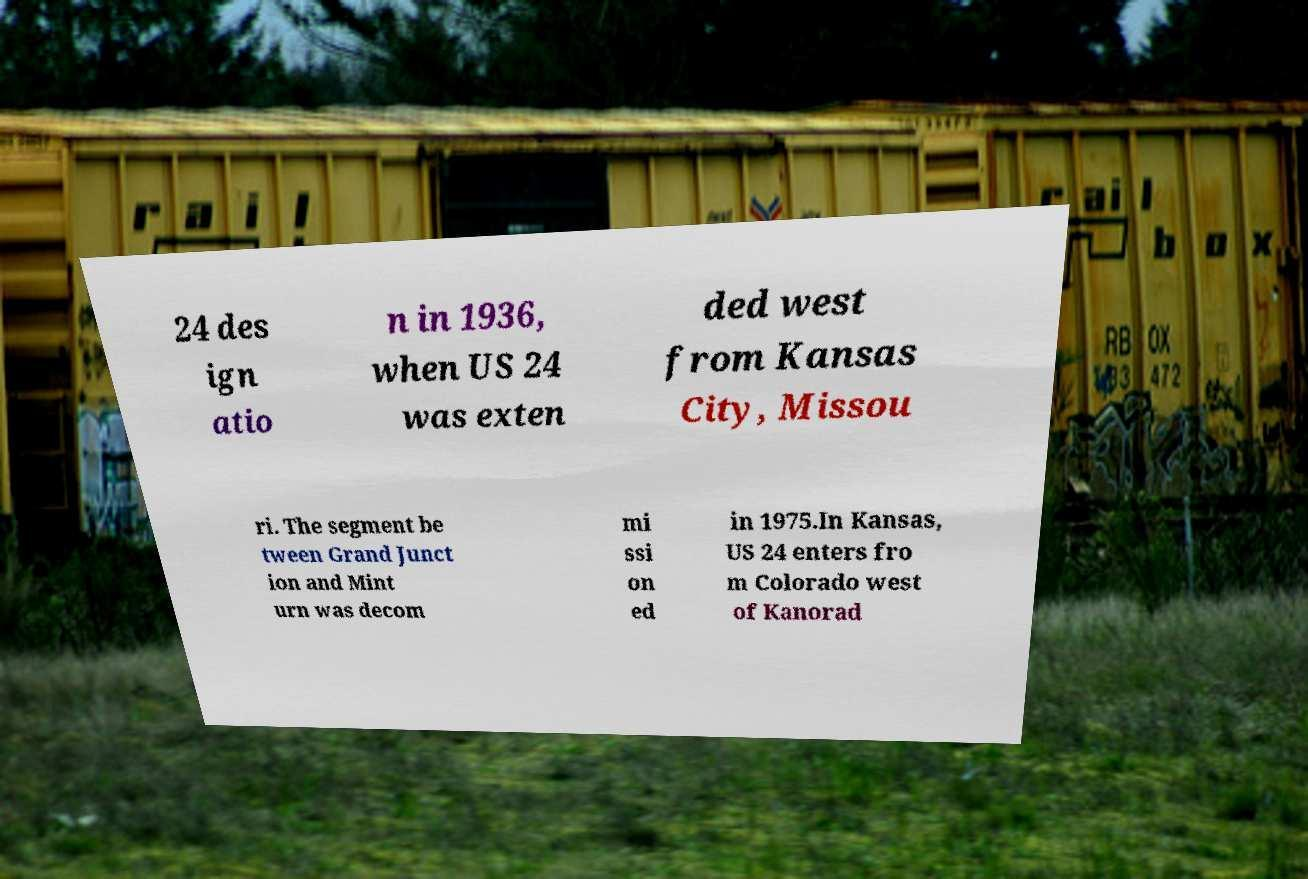For documentation purposes, I need the text within this image transcribed. Could you provide that? 24 des ign atio n in 1936, when US 24 was exten ded west from Kansas City, Missou ri. The segment be tween Grand Junct ion and Mint urn was decom mi ssi on ed in 1975.In Kansas, US 24 enters fro m Colorado west of Kanorad 